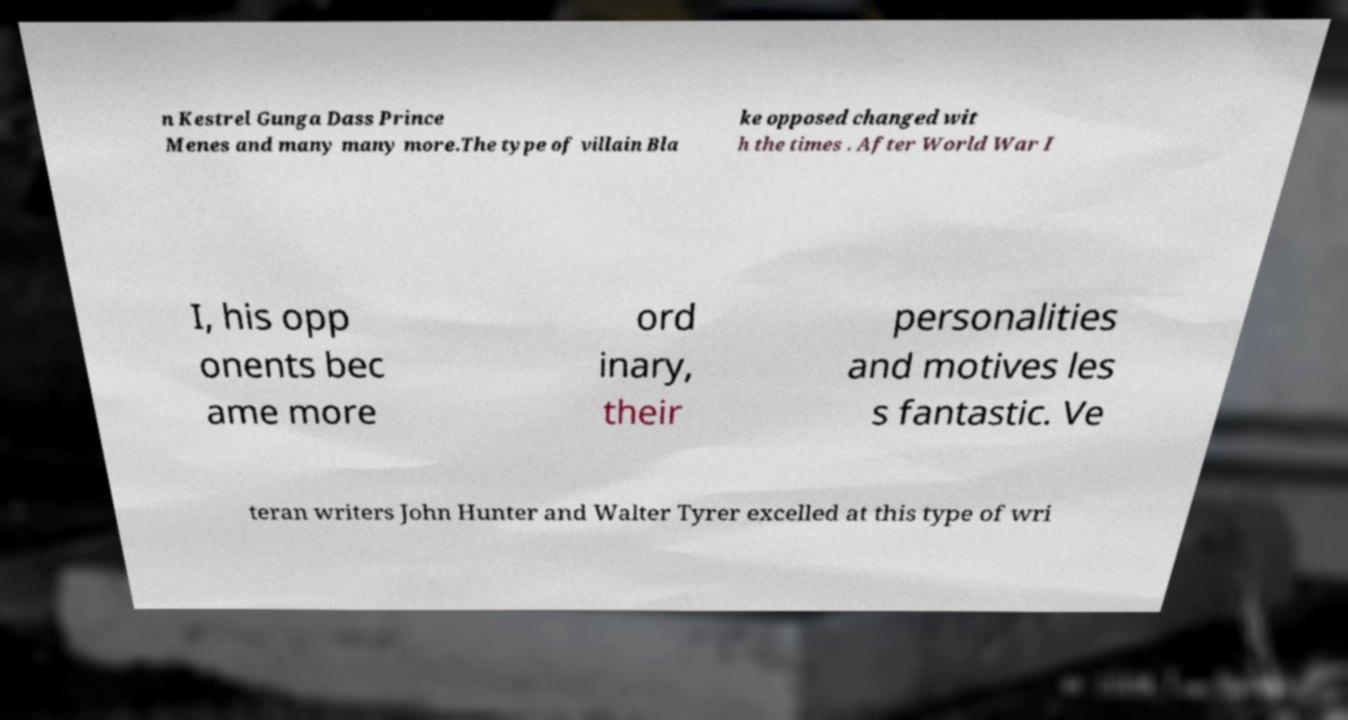Please identify and transcribe the text found in this image. n Kestrel Gunga Dass Prince Menes and many many more.The type of villain Bla ke opposed changed wit h the times . After World War I I, his opp onents bec ame more ord inary, their personalities and motives les s fantastic. Ve teran writers John Hunter and Walter Tyrer excelled at this type of wri 